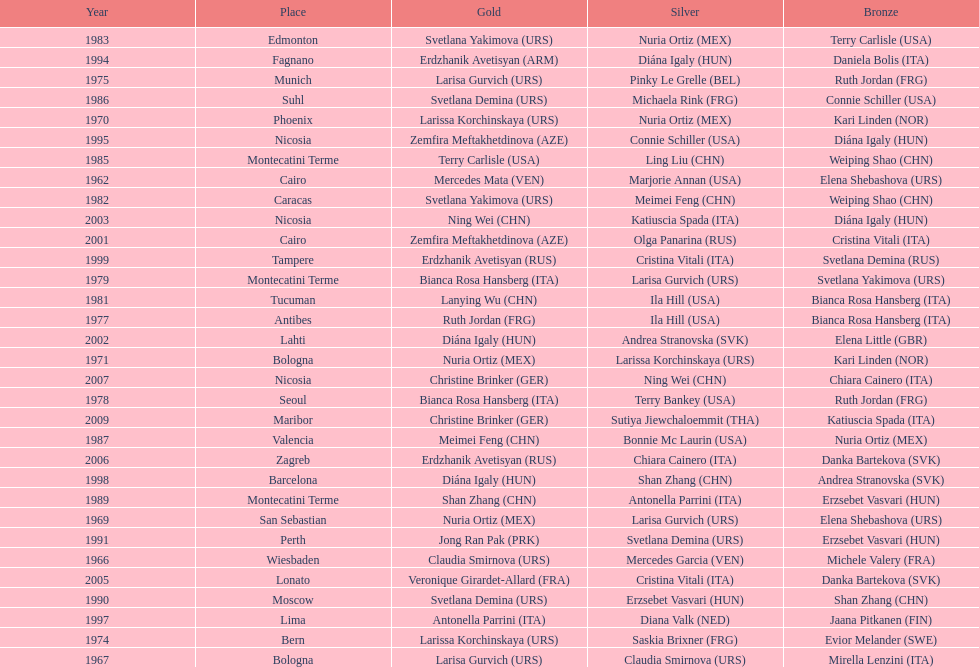What is the total amount of winnings for the united states in gold, silver and bronze? 9. Parse the table in full. {'header': ['Year', 'Place', 'Gold', 'Silver', 'Bronze'], 'rows': [['1983', 'Edmonton', 'Svetlana Yakimova\xa0(URS)', 'Nuria Ortiz\xa0(MEX)', 'Terry Carlisle\xa0(USA)'], ['1994', 'Fagnano', 'Erdzhanik Avetisyan\xa0(ARM)', 'Diána Igaly\xa0(HUN)', 'Daniela Bolis\xa0(ITA)'], ['1975', 'Munich', 'Larisa Gurvich\xa0(URS)', 'Pinky Le Grelle\xa0(BEL)', 'Ruth Jordan\xa0(FRG)'], ['1986', 'Suhl', 'Svetlana Demina\xa0(URS)', 'Michaela Rink\xa0(FRG)', 'Connie Schiller\xa0(USA)'], ['1970', 'Phoenix', 'Larissa Korchinskaya\xa0(URS)', 'Nuria Ortiz\xa0(MEX)', 'Kari Linden\xa0(NOR)'], ['1995', 'Nicosia', 'Zemfira Meftakhetdinova\xa0(AZE)', 'Connie Schiller\xa0(USA)', 'Diána Igaly\xa0(HUN)'], ['1985', 'Montecatini Terme', 'Terry Carlisle\xa0(USA)', 'Ling Liu\xa0(CHN)', 'Weiping Shao\xa0(CHN)'], ['1962', 'Cairo', 'Mercedes Mata\xa0(VEN)', 'Marjorie Annan\xa0(USA)', 'Elena Shebashova\xa0(URS)'], ['1982', 'Caracas', 'Svetlana Yakimova\xa0(URS)', 'Meimei Feng\xa0(CHN)', 'Weiping Shao\xa0(CHN)'], ['2003', 'Nicosia', 'Ning Wei\xa0(CHN)', 'Katiuscia Spada\xa0(ITA)', 'Diána Igaly\xa0(HUN)'], ['2001', 'Cairo', 'Zemfira Meftakhetdinova\xa0(AZE)', 'Olga Panarina\xa0(RUS)', 'Cristina Vitali\xa0(ITA)'], ['1999', 'Tampere', 'Erdzhanik Avetisyan\xa0(RUS)', 'Cristina Vitali\xa0(ITA)', 'Svetlana Demina\xa0(RUS)'], ['1979', 'Montecatini Terme', 'Bianca Rosa Hansberg\xa0(ITA)', 'Larisa Gurvich\xa0(URS)', 'Svetlana Yakimova\xa0(URS)'], ['1981', 'Tucuman', 'Lanying Wu\xa0(CHN)', 'Ila Hill\xa0(USA)', 'Bianca Rosa Hansberg\xa0(ITA)'], ['1977', 'Antibes', 'Ruth Jordan\xa0(FRG)', 'Ila Hill\xa0(USA)', 'Bianca Rosa Hansberg\xa0(ITA)'], ['2002', 'Lahti', 'Diána Igaly\xa0(HUN)', 'Andrea Stranovska\xa0(SVK)', 'Elena Little\xa0(GBR)'], ['1971', 'Bologna', 'Nuria Ortiz\xa0(MEX)', 'Larissa Korchinskaya\xa0(URS)', 'Kari Linden\xa0(NOR)'], ['2007', 'Nicosia', 'Christine Brinker\xa0(GER)', 'Ning Wei\xa0(CHN)', 'Chiara Cainero\xa0(ITA)'], ['1978', 'Seoul', 'Bianca Rosa Hansberg\xa0(ITA)', 'Terry Bankey\xa0(USA)', 'Ruth Jordan\xa0(FRG)'], ['2009', 'Maribor', 'Christine Brinker\xa0(GER)', 'Sutiya Jiewchaloemmit\xa0(THA)', 'Katiuscia Spada\xa0(ITA)'], ['1987', 'Valencia', 'Meimei Feng\xa0(CHN)', 'Bonnie Mc Laurin\xa0(USA)', 'Nuria Ortiz\xa0(MEX)'], ['2006', 'Zagreb', 'Erdzhanik Avetisyan\xa0(RUS)', 'Chiara Cainero\xa0(ITA)', 'Danka Bartekova\xa0(SVK)'], ['1998', 'Barcelona', 'Diána Igaly\xa0(HUN)', 'Shan Zhang\xa0(CHN)', 'Andrea Stranovska\xa0(SVK)'], ['1989', 'Montecatini Terme', 'Shan Zhang\xa0(CHN)', 'Antonella Parrini\xa0(ITA)', 'Erzsebet Vasvari\xa0(HUN)'], ['1969', 'San Sebastian', 'Nuria Ortiz\xa0(MEX)', 'Larisa Gurvich\xa0(URS)', 'Elena Shebashova\xa0(URS)'], ['1991', 'Perth', 'Jong Ran Pak\xa0(PRK)', 'Svetlana Demina\xa0(URS)', 'Erzsebet Vasvari\xa0(HUN)'], ['1966', 'Wiesbaden', 'Claudia Smirnova\xa0(URS)', 'Mercedes Garcia\xa0(VEN)', 'Michele Valery\xa0(FRA)'], ['2005', 'Lonato', 'Veronique Girardet-Allard\xa0(FRA)', 'Cristina Vitali\xa0(ITA)', 'Danka Bartekova\xa0(SVK)'], ['1990', 'Moscow', 'Svetlana Demina\xa0(URS)', 'Erzsebet Vasvari\xa0(HUN)', 'Shan Zhang\xa0(CHN)'], ['1997', 'Lima', 'Antonella Parrini\xa0(ITA)', 'Diana Valk\xa0(NED)', 'Jaana Pitkanen\xa0(FIN)'], ['1974', 'Bern', 'Larissa Korchinskaya\xa0(URS)', 'Saskia Brixner\xa0(FRG)', 'Evior Melander\xa0(SWE)'], ['1967', 'Bologna', 'Larisa Gurvich\xa0(URS)', 'Claudia Smirnova\xa0(URS)', 'Mirella Lenzini\xa0(ITA)']]} 